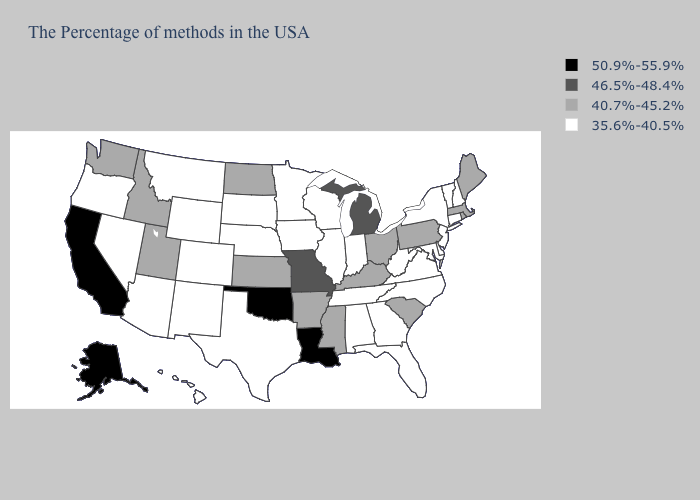What is the value of Maryland?
Be succinct. 35.6%-40.5%. Does Oregon have the lowest value in the USA?
Concise answer only. Yes. What is the value of Louisiana?
Keep it brief. 50.9%-55.9%. Does Wyoming have a lower value than Louisiana?
Write a very short answer. Yes. What is the value of Florida?
Answer briefly. 35.6%-40.5%. Does Texas have a higher value than Missouri?
Keep it brief. No. Does Washington have the lowest value in the West?
Short answer required. No. Name the states that have a value in the range 46.5%-48.4%?
Give a very brief answer. Michigan, Missouri. Is the legend a continuous bar?
Keep it brief. No. What is the value of New York?
Write a very short answer. 35.6%-40.5%. Name the states that have a value in the range 40.7%-45.2%?
Answer briefly. Maine, Massachusetts, Rhode Island, Pennsylvania, South Carolina, Ohio, Kentucky, Mississippi, Arkansas, Kansas, North Dakota, Utah, Idaho, Washington. What is the value of Michigan?
Answer briefly. 46.5%-48.4%. Does Ohio have the lowest value in the USA?
Short answer required. No. What is the value of Kansas?
Give a very brief answer. 40.7%-45.2%. Does the first symbol in the legend represent the smallest category?
Keep it brief. No. 